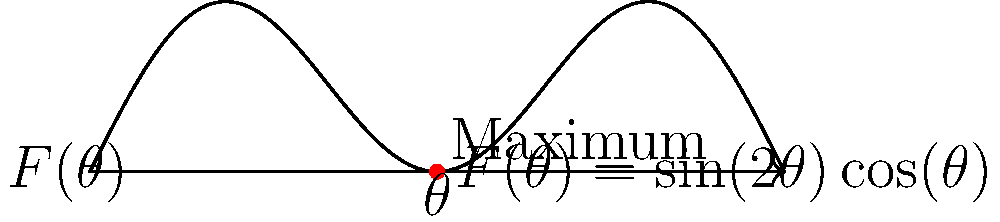In a weightlifting exercise, the force production $F(\theta)$ as a function of the angle $\theta$ (in radians) is given by $F(\theta) = \sin(2\theta)\cos(\theta)$, where $0 \leq \theta \leq \pi$. Find the angle $\theta$ that maximizes the force production and calculate the maximum force. To find the maximum force production, we need to follow these steps:

1) First, we need to find the derivative of $F(\theta)$ with respect to $\theta$:
   $$F'(\theta) = 2\cos(2\theta)\cos(\theta) - \sin(2\theta)\sin(\theta)$$

2) Set the derivative equal to zero to find critical points:
   $$2\cos(2\theta)\cos(\theta) - \sin(2\theta)\sin(\theta) = 0$$

3) Using trigonometric identities, we can simplify:
   $$2(\cos^2(\theta) - \sin^2(\theta))\cos(\theta) - 2\sin(\theta)\cos(\theta)\sin(\theta) = 0$$
   $$2\cos^3(\theta) - 2\sin^2(\theta)\cos(\theta) - 2\sin^2(\theta)\cos(\theta) = 0$$
   $$2\cos(\theta)(\cos^2(\theta) - 2\sin^2(\theta)) = 0$$

4) Solve this equation:
   Either $\cos(\theta) = 0$ or $\cos^2(\theta) - 2\sin^2(\theta) = 0$
   
   If $\cos(\theta) = 0$, then $\theta = \pi/2$
   
   If $\cos^2(\theta) - 2\sin^2(\theta) = 0$, then:
   $\cos^2(\theta) = 2\sin^2(\theta)$
   $\cos^2(\theta) = 2(1-\cos^2(\theta))$
   $3\cos^2(\theta) = 2$
   $\cos^2(\theta) = 2/3$
   $\cos(\theta) = \sqrt{2/3}$ or $\cos(\theta) = -\sqrt{2/3}$
   
   $\theta = \arccos(\sqrt{2/3}) \approx 0.615$ radians or $\theta = \arccos(-\sqrt{2/3}) \approx 2.526$ radians

5) Evaluate $F(\theta)$ at these critical points:
   $F(\pi/2) = 0$
   $F(0.615) \approx 0.385$
   $F(2.526) \approx -0.385$

6) The maximum occurs at $\theta \approx 0.615$ radians or about 35.26 degrees.

7) The maximum force is $F(0.615) \approx 0.385$.
Answer: $\theta \approx 0.615$ radians (35.26°), $F_{max} \approx 0.385$ 